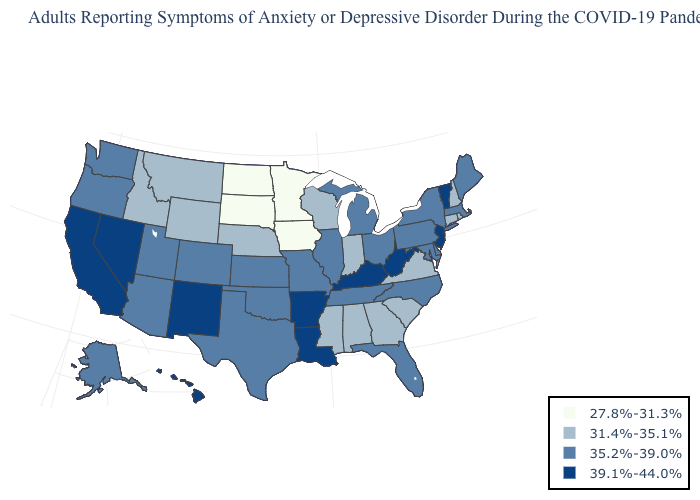Among the states that border Mississippi , does Alabama have the lowest value?
Concise answer only. Yes. Which states have the lowest value in the West?
Short answer required. Idaho, Montana, Wyoming. Name the states that have a value in the range 35.2%-39.0%?
Answer briefly. Alaska, Arizona, Colorado, Delaware, Florida, Illinois, Kansas, Maine, Maryland, Massachusetts, Michigan, Missouri, New York, North Carolina, Ohio, Oklahoma, Oregon, Pennsylvania, Tennessee, Texas, Utah, Washington. Does South Carolina have the same value as Alabama?
Short answer required. Yes. Which states have the lowest value in the South?
Quick response, please. Alabama, Georgia, Mississippi, South Carolina, Virginia. Name the states that have a value in the range 31.4%-35.1%?
Give a very brief answer. Alabama, Connecticut, Georgia, Idaho, Indiana, Mississippi, Montana, Nebraska, New Hampshire, Rhode Island, South Carolina, Virginia, Wisconsin, Wyoming. Does Vermont have the lowest value in the Northeast?
Short answer required. No. How many symbols are there in the legend?
Short answer required. 4. Name the states that have a value in the range 31.4%-35.1%?
Answer briefly. Alabama, Connecticut, Georgia, Idaho, Indiana, Mississippi, Montana, Nebraska, New Hampshire, Rhode Island, South Carolina, Virginia, Wisconsin, Wyoming. What is the value of Missouri?
Answer briefly. 35.2%-39.0%. Name the states that have a value in the range 39.1%-44.0%?
Write a very short answer. Arkansas, California, Hawaii, Kentucky, Louisiana, Nevada, New Jersey, New Mexico, Vermont, West Virginia. What is the value of Indiana?
Give a very brief answer. 31.4%-35.1%. Which states have the lowest value in the West?
Concise answer only. Idaho, Montana, Wyoming. What is the value of New York?
Give a very brief answer. 35.2%-39.0%. What is the value of Connecticut?
Concise answer only. 31.4%-35.1%. 